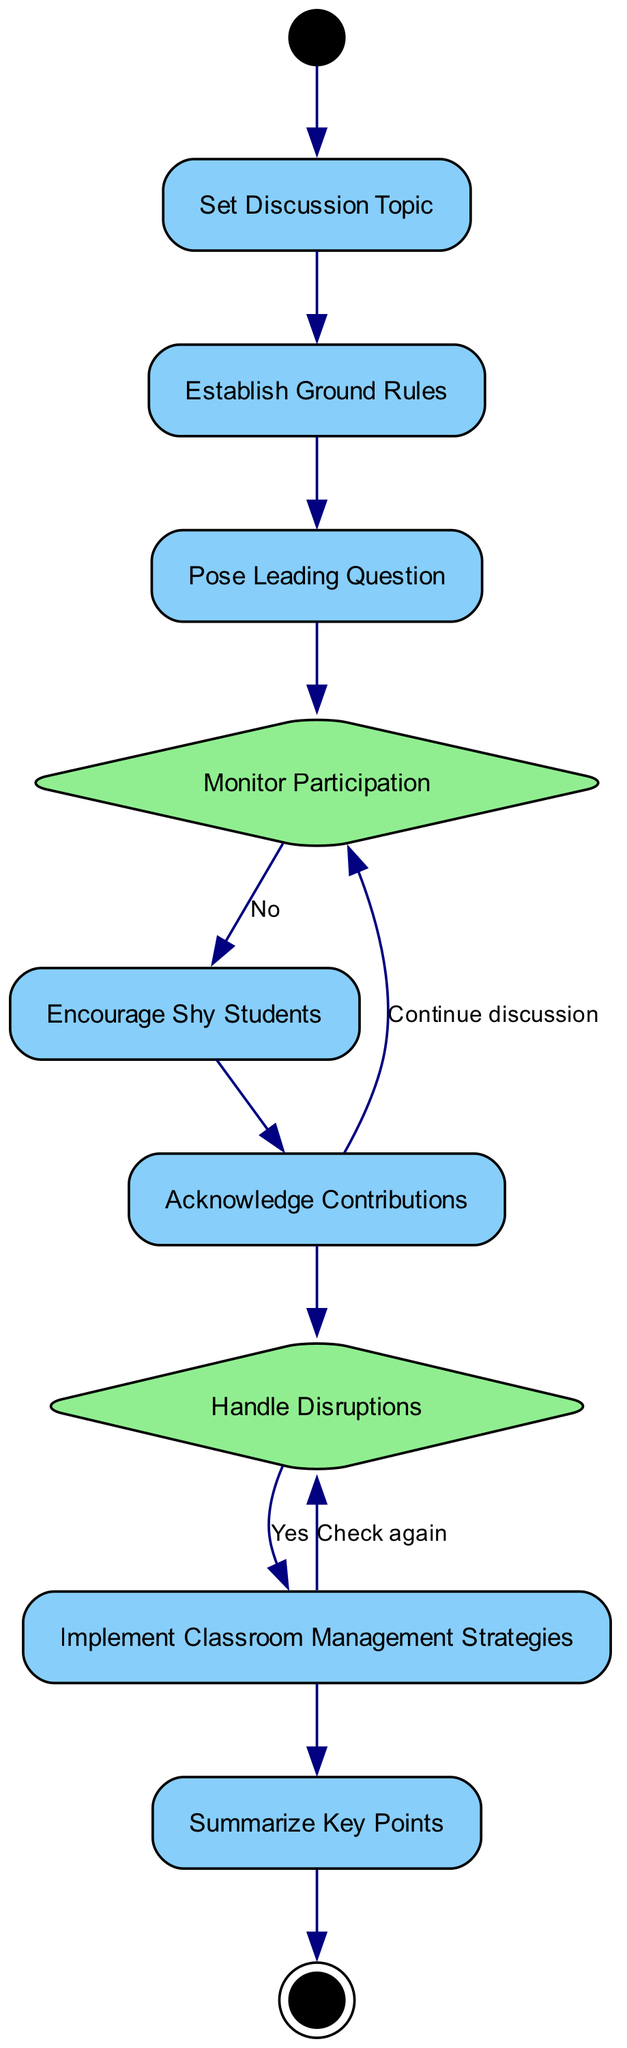What is the first action in the diagram? The first action node listed in the diagram is "Set Discussion Topic," which follows the initial node marking the start of the discussion.
Answer: Set Discussion Topic How many action nodes are there in total? The total number of action nodes is calculated by examining all elements of the type "Action": "Set Discussion Topic," "Establish Ground Rules," "Pose Leading Question," "Encourage Shy Students," "Acknowledge Contributions," "Implement Classroom Management Strategies," and "Summarize Key Points". There are 7 action nodes.
Answer: 7 What is the purpose of the node "Establish Ground Rules"? The node "Establish Ground Rules" describes the activity where the teacher and students agree on important guidelines that will guide the discussion process.
Answer: Teacher and students agree on rules Which action follows the "Monitor Participation" decision? After the "Monitor Participation" decision, if students are participating, the next action encountered is "Acknowledge Contributions." Thus, this action directly follows this decision.
Answer: Acknowledge Contributions What happens if there are behavioral disruptions? If behavioral disruptions are detected, the flow leads to the action "Implement Classroom Management Strategies," indicating the teacher's response to handle such disruptions effectively.
Answer: Implement Classroom Management Strategies How many total nodes are in the diagram? The total number of nodes is obtained by counting all types of nodes including Initial Node, Action, Decision, and Final Node, which sums up to 11 in the diagram.
Answer: 11 What happens after "Acknowledge Contributions"? Following "Acknowledge Contributions," the flow returns to "Monitor Participation," indicating a loop where the teacher continuously assesses student participation.
Answer: Monitor Participation What do you do if shy students are not encouraged? If the decision flow leads to "Encourage Shy Students" and it is determined they are not encouraged, the discussion continues without adjustments for their participation.
Answer: Continue discussion What does the final node represent? The final node, labeled "End Discussion," signifies the conclusion of the group discussion activity, indicating that no further steps will be taken in this flow.
Answer: End Discussion 